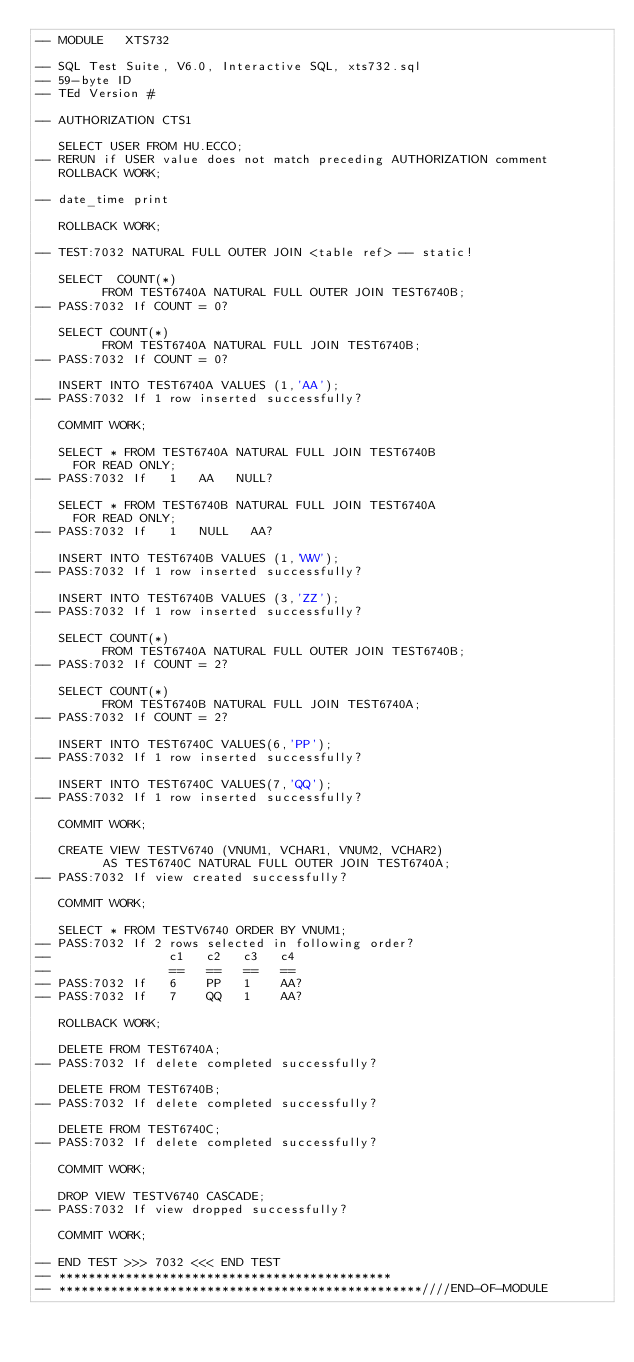Convert code to text. <code><loc_0><loc_0><loc_500><loc_500><_SQL_>-- MODULE   XTS732

-- SQL Test Suite, V6.0, Interactive SQL, xts732.sql
-- 59-byte ID
-- TEd Version #

-- AUTHORIZATION CTS1              

   SELECT USER FROM HU.ECCO;
-- RERUN if USER value does not match preceding AUTHORIZATION comment
   ROLLBACK WORK;

-- date_time print

   ROLLBACK WORK;

-- TEST:7032 NATURAL FULL OUTER JOIN <table ref> -- static!

   SELECT  COUNT(*) 
         FROM TEST6740A NATURAL FULL OUTER JOIN TEST6740B;
-- PASS:7032 If COUNT = 0?

   SELECT COUNT(*) 
         FROM TEST6740A NATURAL FULL JOIN TEST6740B;
-- PASS:7032 If COUNT = 0?

   INSERT INTO TEST6740A VALUES (1,'AA');
-- PASS:7032 If 1 row inserted successfully?

   COMMIT WORK;

   SELECT * FROM TEST6740A NATURAL FULL JOIN TEST6740B 
     FOR READ ONLY;
-- PASS:7032 If   1   AA   NULL?

   SELECT * FROM TEST6740B NATURAL FULL JOIN TEST6740A 
     FOR READ ONLY;
-- PASS:7032 If   1   NULL   AA?

   INSERT INTO TEST6740B VALUES (1,'WW');
-- PASS:7032 If 1 row inserted successfully?

   INSERT INTO TEST6740B VALUES (3,'ZZ');
-- PASS:7032 If 1 row inserted successfully?

   SELECT COUNT(*) 
         FROM TEST6740A NATURAL FULL OUTER JOIN TEST6740B;
-- PASS:7032 If COUNT = 2?

   SELECT COUNT(*) 
         FROM TEST6740B NATURAL FULL JOIN TEST6740A;
-- PASS:7032 If COUNT = 2?

   INSERT INTO TEST6740C VALUES(6,'PP');
-- PASS:7032 If 1 row inserted successfully?

   INSERT INTO TEST6740C VALUES(7,'QQ');
-- PASS:7032 If 1 row inserted successfully?

   COMMIT WORK;

   CREATE VIEW TESTV6740 (VNUM1, VCHAR1, VNUM2, VCHAR2)
         AS TEST6740C NATURAL FULL OUTER JOIN TEST6740A;
-- PASS:7032 If view created successfully?

   COMMIT WORK;

   SELECT * FROM TESTV6740 ORDER BY VNUM1;
-- PASS:7032 If 2 rows selected in following order?
--                c1   c2   c3   c4
--                ==   ==   ==   ==
-- PASS:7032 If   6    PP   1    AA?
-- PASS:7032 If   7    QQ   1    AA?

   ROLLBACK WORK;

   DELETE FROM TEST6740A;
-- PASS:7032 If delete completed successfully?

   DELETE FROM TEST6740B;
-- PASS:7032 If delete completed successfully?

   DELETE FROM TEST6740C;
-- PASS:7032 If delete completed successfully?

   COMMIT WORK;

   DROP VIEW TESTV6740 CASCADE;
-- PASS:7032 If view dropped successfully?

   COMMIT WORK;

-- END TEST >>> 7032 <<< END TEST
-- *********************************************
-- *************************************************////END-OF-MODULE
</code> 